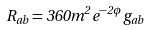Convert formula to latex. <formula><loc_0><loc_0><loc_500><loc_500>R _ { a b } = 3 6 0 m ^ { 2 } e ^ { - 2 \phi } g _ { a b }</formula> 